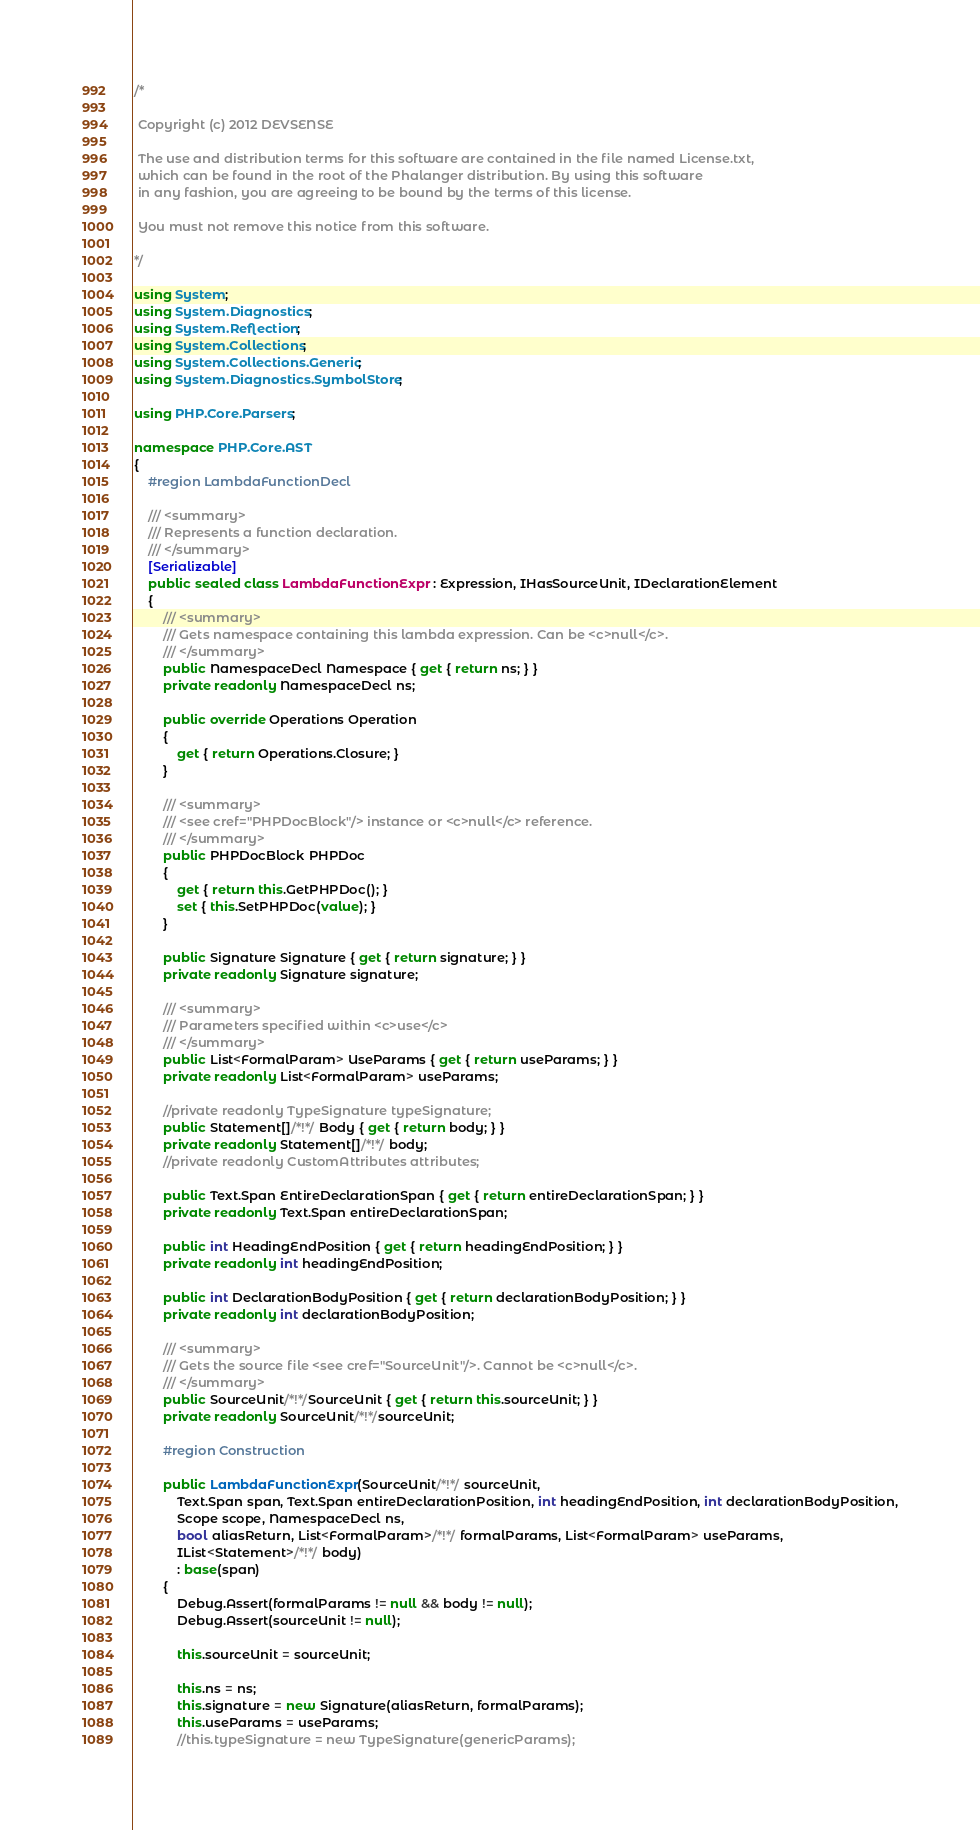Convert code to text. <code><loc_0><loc_0><loc_500><loc_500><_C#_>/*

 Copyright (c) 2012 DEVSENSE

 The use and distribution terms for this software are contained in the file named License.txt, 
 which can be found in the root of the Phalanger distribution. By using this software 
 in any fashion, you are agreeing to be bound by the terms of this license.
 
 You must not remove this notice from this software.

*/

using System;
using System.Diagnostics;
using System.Reflection;
using System.Collections;
using System.Collections.Generic;
using System.Diagnostics.SymbolStore;

using PHP.Core.Parsers;

namespace PHP.Core.AST
{
    #region LambdaFunctionDecl

    /// <summary>
    /// Represents a function declaration.
    /// </summary>
    [Serializable]
    public sealed class LambdaFunctionExpr : Expression, IHasSourceUnit, IDeclarationElement
    {
        /// <summary>
        /// Gets namespace containing this lambda expression. Can be <c>null</c>.
        /// </summary>
        public NamespaceDecl Namespace { get { return ns; } }
        private readonly NamespaceDecl ns;

        public override Operations Operation
        {
            get { return Operations.Closure; }
        }

        /// <summary>
        /// <see cref="PHPDocBlock"/> instance or <c>null</c> reference.
        /// </summary>
        public PHPDocBlock PHPDoc
        {
            get { return this.GetPHPDoc(); }
            set { this.SetPHPDoc(value); }
        }

        public Signature Signature { get { return signature; } }
        private readonly Signature signature;

        /// <summary>
        /// Parameters specified within <c>use</c> 
        /// </summary>
        public List<FormalParam> UseParams { get { return useParams; } }
        private readonly List<FormalParam> useParams;

        //private readonly TypeSignature typeSignature;
        public Statement[]/*!*/ Body { get { return body; } }
        private readonly Statement[]/*!*/ body;
        //private readonly CustomAttributes attributes;

        public Text.Span EntireDeclarationSpan { get { return entireDeclarationSpan; } }
        private readonly Text.Span entireDeclarationSpan;

        public int HeadingEndPosition { get { return headingEndPosition; } }
        private readonly int headingEndPosition;

        public int DeclarationBodyPosition { get { return declarationBodyPosition; } }
        private readonly int declarationBodyPosition;

        /// <summary>
        /// Gets the source file <see cref="SourceUnit"/>. Cannot be <c>null</c>.
        /// </summary>
        public SourceUnit/*!*/SourceUnit { get { return this.sourceUnit; } }
        private readonly SourceUnit/*!*/sourceUnit;

        #region Construction

        public LambdaFunctionExpr(SourceUnit/*!*/ sourceUnit,
            Text.Span span, Text.Span entireDeclarationPosition, int headingEndPosition, int declarationBodyPosition,
            Scope scope, NamespaceDecl ns,
            bool aliasReturn, List<FormalParam>/*!*/ formalParams, List<FormalParam> useParams,
            IList<Statement>/*!*/ body)
            : base(span)
        {
            Debug.Assert(formalParams != null && body != null);
            Debug.Assert(sourceUnit != null);

            this.sourceUnit = sourceUnit;
            
            this.ns = ns;
            this.signature = new Signature(aliasReturn, formalParams);
            this.useParams = useParams;
            //this.typeSignature = new TypeSignature(genericParams);</code> 